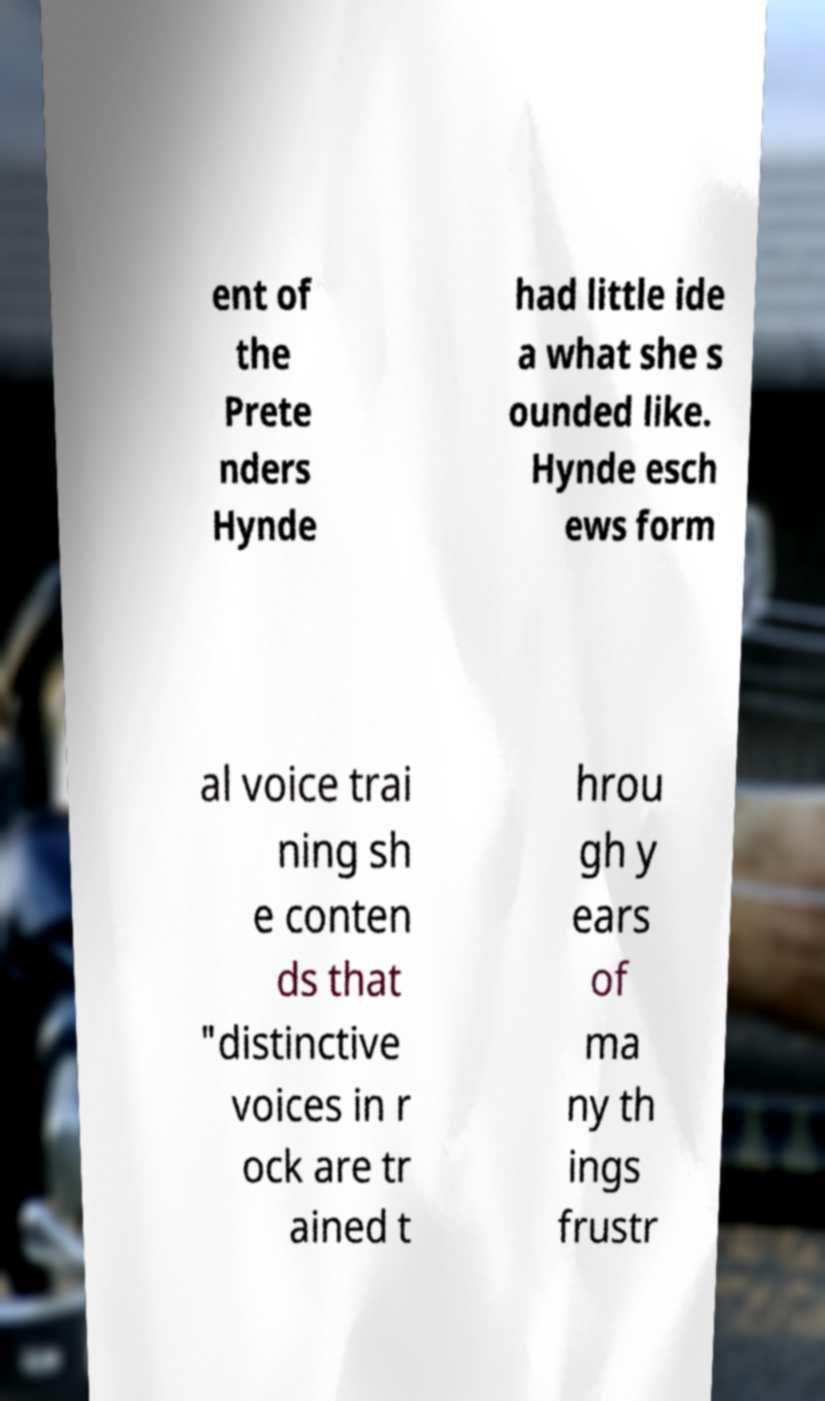Could you extract and type out the text from this image? ent of the Prete nders Hynde had little ide a what she s ounded like. Hynde esch ews form al voice trai ning sh e conten ds that "distinctive voices in r ock are tr ained t hrou gh y ears of ma ny th ings frustr 